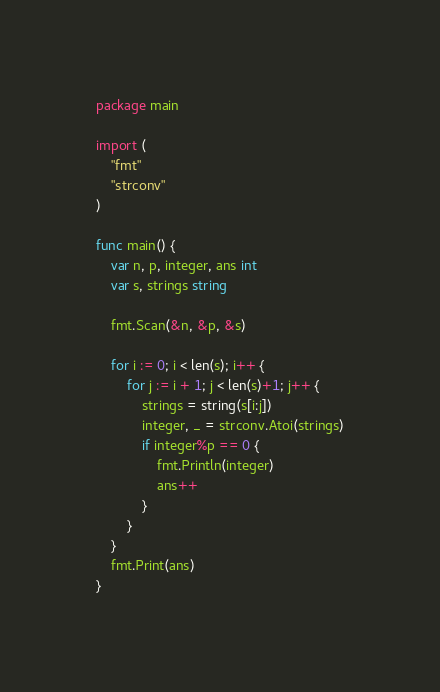Convert code to text. <code><loc_0><loc_0><loc_500><loc_500><_Go_>package main

import (
	"fmt"
	"strconv"
)

func main() {
	var n, p, integer, ans int
	var s, strings string

	fmt.Scan(&n, &p, &s)

	for i := 0; i < len(s); i++ {
		for j := i + 1; j < len(s)+1; j++ {
			strings = string(s[i:j])
			integer, _ = strconv.Atoi(strings)
			if integer%p == 0 {
				fmt.Println(integer)
				ans++
			}
		}
	}
	fmt.Print(ans)
}</code> 